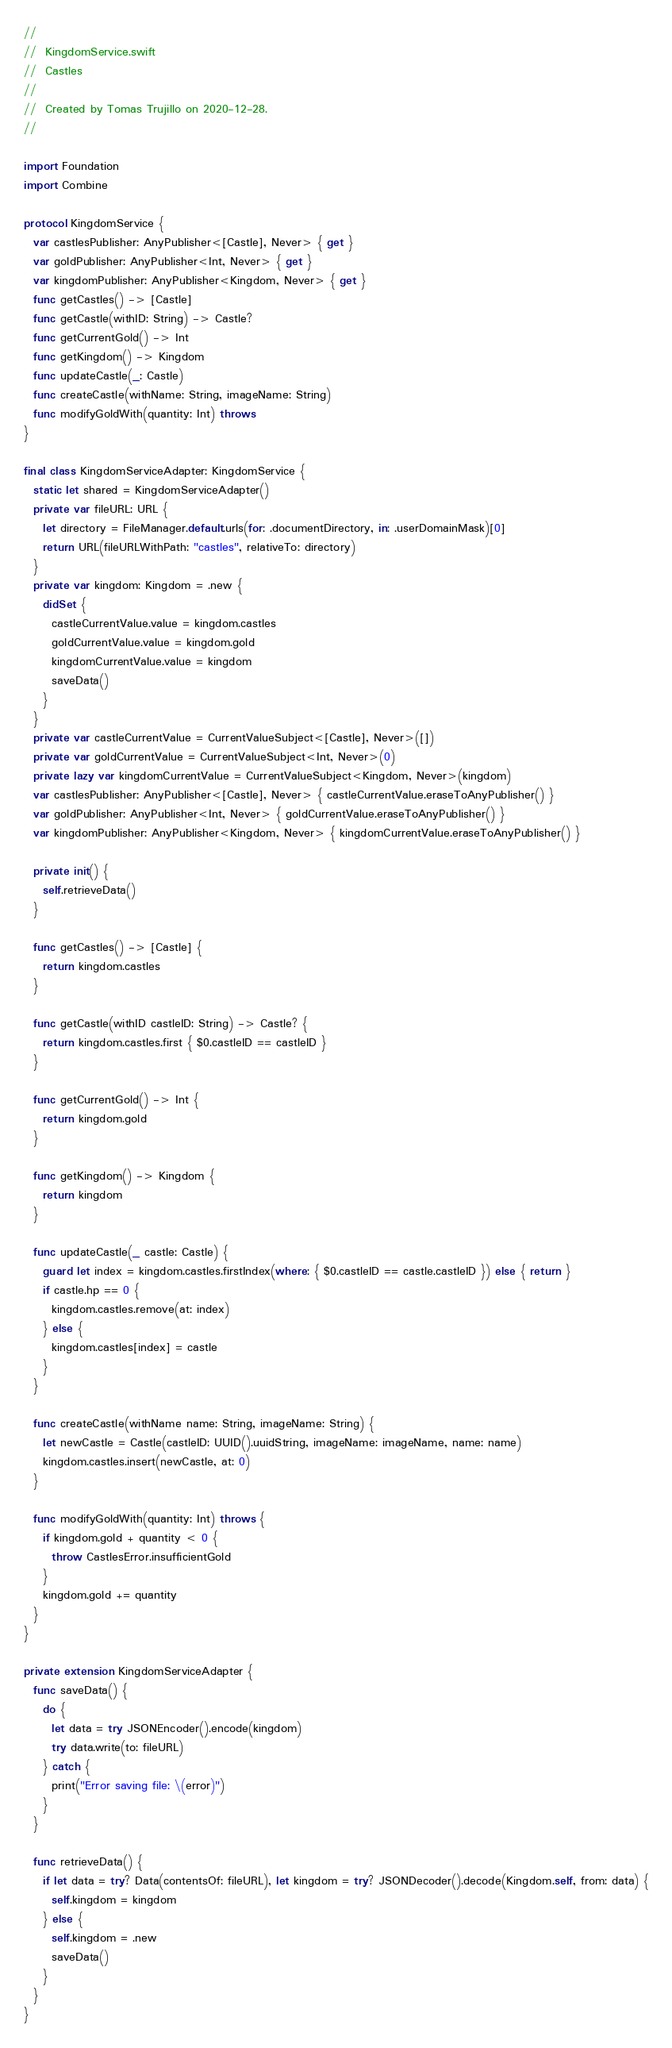Convert code to text. <code><loc_0><loc_0><loc_500><loc_500><_Swift_>//
//  KingdomService.swift
//  Castles
//
//  Created by Tomas Trujillo on 2020-12-28.
//

import Foundation
import Combine

protocol KingdomService {
  var castlesPublisher: AnyPublisher<[Castle], Never> { get }
  var goldPublisher: AnyPublisher<Int, Never> { get }
  var kingdomPublisher: AnyPublisher<Kingdom, Never> { get }
  func getCastles() -> [Castle]
  func getCastle(withID: String) -> Castle?
  func getCurrentGold() -> Int
  func getKingdom() -> Kingdom
  func updateCastle(_: Castle)
  func createCastle(withName: String, imageName: String)
  func modifyGoldWith(quantity: Int) throws
}

final class KingdomServiceAdapter: KingdomService {
  static let shared = KingdomServiceAdapter()
  private var fileURL: URL {
    let directory = FileManager.default.urls(for: .documentDirectory, in: .userDomainMask)[0]
    return URL(fileURLWithPath: "castles", relativeTo: directory)
  }
  private var kingdom: Kingdom = .new {
    didSet {
      castleCurrentValue.value = kingdom.castles
      goldCurrentValue.value = kingdom.gold
      kingdomCurrentValue.value = kingdom
      saveData()
    }
  }
  private var castleCurrentValue = CurrentValueSubject<[Castle], Never>([])
  private var goldCurrentValue = CurrentValueSubject<Int, Never>(0)
  private lazy var kingdomCurrentValue = CurrentValueSubject<Kingdom, Never>(kingdom)
  var castlesPublisher: AnyPublisher<[Castle], Never> { castleCurrentValue.eraseToAnyPublisher() }
  var goldPublisher: AnyPublisher<Int, Never> { goldCurrentValue.eraseToAnyPublisher() }
  var kingdomPublisher: AnyPublisher<Kingdom, Never> { kingdomCurrentValue.eraseToAnyPublisher() }
  
  private init() {
    self.retrieveData()
  }
  
  func getCastles() -> [Castle] {
    return kingdom.castles
  }
  
  func getCastle(withID castleID: String) -> Castle? {
    return kingdom.castles.first { $0.castleID == castleID }
  }
  
  func getCurrentGold() -> Int {
    return kingdom.gold
  }
  
  func getKingdom() -> Kingdom {
    return kingdom
  }
  
  func updateCastle(_ castle: Castle) {
    guard let index = kingdom.castles.firstIndex(where: { $0.castleID == castle.castleID }) else { return }
    if castle.hp == 0 {
      kingdom.castles.remove(at: index)
    } else {
      kingdom.castles[index] = castle
    }
  }
  
  func createCastle(withName name: String, imageName: String) {
    let newCastle = Castle(castleID: UUID().uuidString, imageName: imageName, name: name)
    kingdom.castles.insert(newCastle, at: 0)
  }
  
  func modifyGoldWith(quantity: Int) throws {
    if kingdom.gold + quantity < 0 {
      throw CastlesError.insufficientGold
    }
    kingdom.gold += quantity
  }
}

private extension KingdomServiceAdapter {
  func saveData() {
    do {
      let data = try JSONEncoder().encode(kingdom)
      try data.write(to: fileURL)
    } catch {
      print("Error saving file: \(error)")
    }
  }
  
  func retrieveData() {
    if let data = try? Data(contentsOf: fileURL), let kingdom = try? JSONDecoder().decode(Kingdom.self, from: data) {
      self.kingdom = kingdom
    } else {
      self.kingdom = .new
      saveData()
    }
  }
}
</code> 